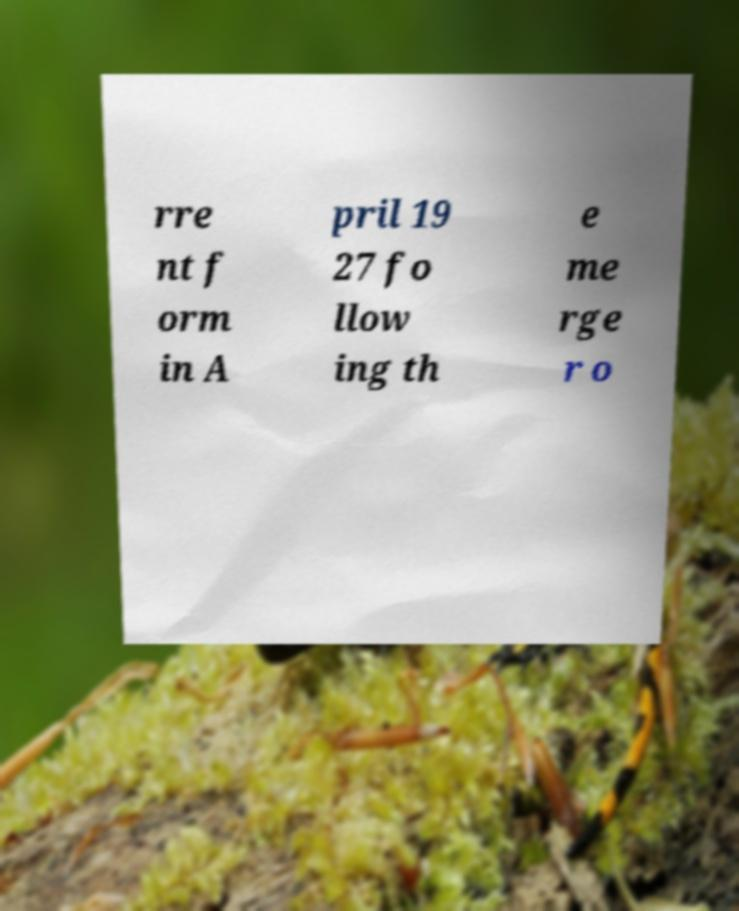For documentation purposes, I need the text within this image transcribed. Could you provide that? rre nt f orm in A pril 19 27 fo llow ing th e me rge r o 